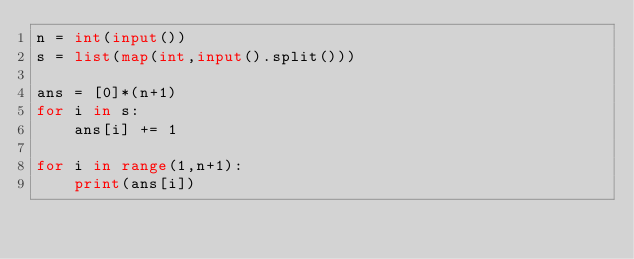<code> <loc_0><loc_0><loc_500><loc_500><_Python_>n = int(input())
s = list(map(int,input().split()))

ans = [0]*(n+1)
for i in s:
    ans[i] += 1

for i in range(1,n+1):
    print(ans[i])
</code> 